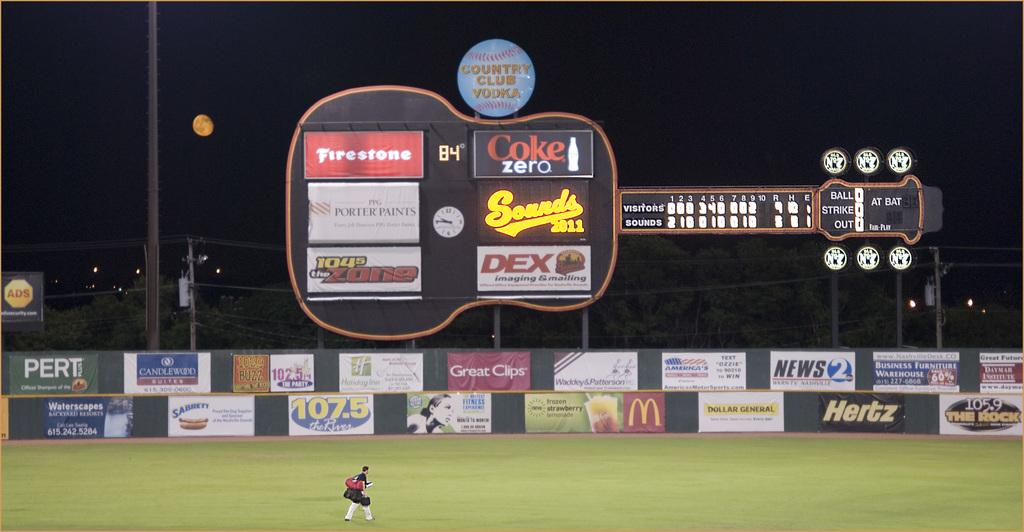Provide a one-sentence caption for the provided image. A baseball score board shaped like a guitar with a variety of advertising signs on the score board and on the fence below it. 